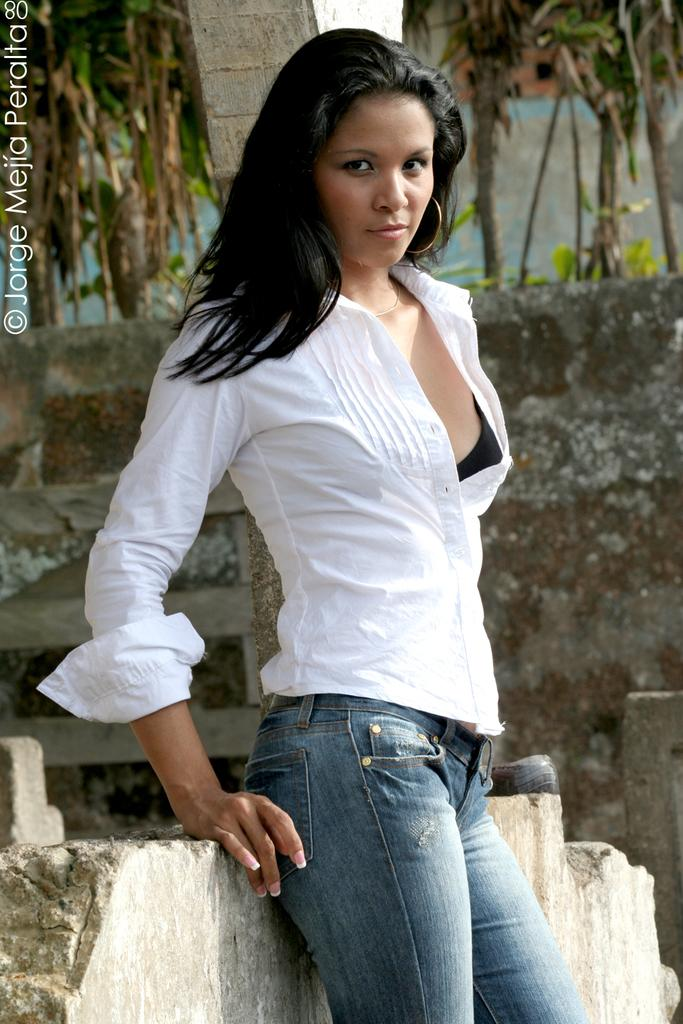Who is the main subject in the image? There is a lady in the image. What is the lady wearing? The lady is wearing a white shirt. What can be seen in the background of the image? There are trees and a wall in the background of the image. Where is the text located in the image? The text is on the left side of the image. What type of knife is the lady using to cut the veil in the image? There is no knife or veil present in the image. How much dust can be seen on the lady's white shirt in the image? There is no dust visible on the lady's white shirt in the image. 